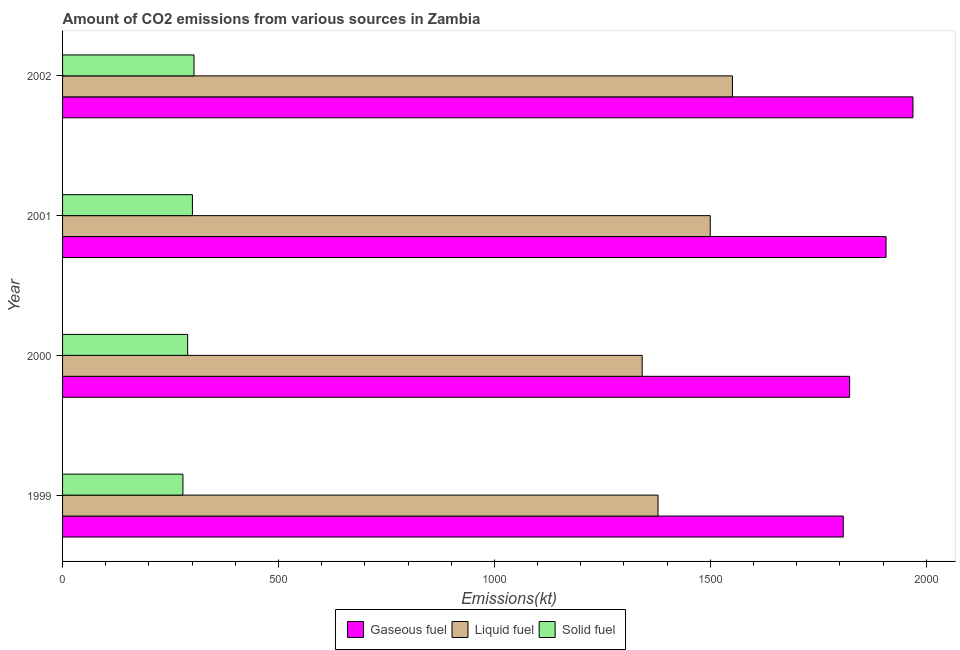How many different coloured bars are there?
Keep it short and to the point. 3. Are the number of bars per tick equal to the number of legend labels?
Make the answer very short. Yes. Are the number of bars on each tick of the Y-axis equal?
Provide a succinct answer. Yes. How many bars are there on the 4th tick from the top?
Make the answer very short. 3. What is the label of the 2nd group of bars from the top?
Your response must be concise. 2001. In how many cases, is the number of bars for a given year not equal to the number of legend labels?
Make the answer very short. 0. What is the amount of co2 emissions from gaseous fuel in 2000?
Provide a short and direct response. 1822.5. Across all years, what is the maximum amount of co2 emissions from solid fuel?
Offer a terse response. 304.36. Across all years, what is the minimum amount of co2 emissions from gaseous fuel?
Your response must be concise. 1807.83. In which year was the amount of co2 emissions from liquid fuel maximum?
Make the answer very short. 2002. In which year was the amount of co2 emissions from solid fuel minimum?
Give a very brief answer. 1999. What is the total amount of co2 emissions from solid fuel in the graph?
Offer a terse response. 1173.44. What is the difference between the amount of co2 emissions from gaseous fuel in 2000 and that in 2001?
Provide a short and direct response. -84.34. What is the difference between the amount of co2 emissions from solid fuel in 2000 and the amount of co2 emissions from liquid fuel in 2002?
Provide a succinct answer. -1261.45. What is the average amount of co2 emissions from liquid fuel per year?
Provide a succinct answer. 1442.96. In the year 2000, what is the difference between the amount of co2 emissions from gaseous fuel and amount of co2 emissions from liquid fuel?
Provide a short and direct response. 480.38. What is the ratio of the amount of co2 emissions from gaseous fuel in 1999 to that in 2001?
Ensure brevity in your answer.  0.95. Is the amount of co2 emissions from liquid fuel in 1999 less than that in 2000?
Keep it short and to the point. No. Is the difference between the amount of co2 emissions from gaseous fuel in 2000 and 2001 greater than the difference between the amount of co2 emissions from solid fuel in 2000 and 2001?
Offer a very short reply. No. What is the difference between the highest and the second highest amount of co2 emissions from gaseous fuel?
Offer a very short reply. 62.34. What is the difference between the highest and the lowest amount of co2 emissions from liquid fuel?
Provide a short and direct response. 209.02. In how many years, is the amount of co2 emissions from liquid fuel greater than the average amount of co2 emissions from liquid fuel taken over all years?
Your answer should be compact. 2. Is the sum of the amount of co2 emissions from liquid fuel in 2000 and 2002 greater than the maximum amount of co2 emissions from gaseous fuel across all years?
Provide a succinct answer. Yes. What does the 2nd bar from the top in 2001 represents?
Make the answer very short. Liquid fuel. What does the 3rd bar from the bottom in 1999 represents?
Make the answer very short. Solid fuel. Is it the case that in every year, the sum of the amount of co2 emissions from gaseous fuel and amount of co2 emissions from liquid fuel is greater than the amount of co2 emissions from solid fuel?
Provide a succinct answer. Yes. How many bars are there?
Provide a succinct answer. 12. What is the difference between two consecutive major ticks on the X-axis?
Ensure brevity in your answer.  500. Does the graph contain any zero values?
Give a very brief answer. No. Where does the legend appear in the graph?
Your response must be concise. Bottom center. How many legend labels are there?
Your answer should be compact. 3. What is the title of the graph?
Your answer should be compact. Amount of CO2 emissions from various sources in Zambia. What is the label or title of the X-axis?
Your answer should be compact. Emissions(kt). What is the Emissions(kt) in Gaseous fuel in 1999?
Ensure brevity in your answer.  1807.83. What is the Emissions(kt) in Liquid fuel in 1999?
Provide a succinct answer. 1378.79. What is the Emissions(kt) of Solid fuel in 1999?
Offer a terse response. 278.69. What is the Emissions(kt) in Gaseous fuel in 2000?
Ensure brevity in your answer.  1822.5. What is the Emissions(kt) of Liquid fuel in 2000?
Provide a short and direct response. 1342.12. What is the Emissions(kt) of Solid fuel in 2000?
Ensure brevity in your answer.  289.69. What is the Emissions(kt) of Gaseous fuel in 2001?
Offer a terse response. 1906.84. What is the Emissions(kt) in Liquid fuel in 2001?
Ensure brevity in your answer.  1499.8. What is the Emissions(kt) in Solid fuel in 2001?
Your response must be concise. 300.69. What is the Emissions(kt) of Gaseous fuel in 2002?
Your answer should be very brief. 1969.18. What is the Emissions(kt) in Liquid fuel in 2002?
Give a very brief answer. 1551.14. What is the Emissions(kt) of Solid fuel in 2002?
Your response must be concise. 304.36. Across all years, what is the maximum Emissions(kt) in Gaseous fuel?
Provide a short and direct response. 1969.18. Across all years, what is the maximum Emissions(kt) in Liquid fuel?
Make the answer very short. 1551.14. Across all years, what is the maximum Emissions(kt) of Solid fuel?
Provide a succinct answer. 304.36. Across all years, what is the minimum Emissions(kt) of Gaseous fuel?
Your response must be concise. 1807.83. Across all years, what is the minimum Emissions(kt) of Liquid fuel?
Give a very brief answer. 1342.12. Across all years, what is the minimum Emissions(kt) in Solid fuel?
Your response must be concise. 278.69. What is the total Emissions(kt) of Gaseous fuel in the graph?
Offer a terse response. 7506.35. What is the total Emissions(kt) in Liquid fuel in the graph?
Ensure brevity in your answer.  5771.86. What is the total Emissions(kt) in Solid fuel in the graph?
Your answer should be compact. 1173.44. What is the difference between the Emissions(kt) in Gaseous fuel in 1999 and that in 2000?
Ensure brevity in your answer.  -14.67. What is the difference between the Emissions(kt) in Liquid fuel in 1999 and that in 2000?
Give a very brief answer. 36.67. What is the difference between the Emissions(kt) in Solid fuel in 1999 and that in 2000?
Offer a terse response. -11. What is the difference between the Emissions(kt) in Gaseous fuel in 1999 and that in 2001?
Keep it short and to the point. -99.01. What is the difference between the Emissions(kt) in Liquid fuel in 1999 and that in 2001?
Keep it short and to the point. -121.01. What is the difference between the Emissions(kt) of Solid fuel in 1999 and that in 2001?
Offer a terse response. -22. What is the difference between the Emissions(kt) of Gaseous fuel in 1999 and that in 2002?
Your response must be concise. -161.35. What is the difference between the Emissions(kt) of Liquid fuel in 1999 and that in 2002?
Provide a short and direct response. -172.35. What is the difference between the Emissions(kt) of Solid fuel in 1999 and that in 2002?
Your answer should be compact. -25.67. What is the difference between the Emissions(kt) of Gaseous fuel in 2000 and that in 2001?
Your answer should be compact. -84.34. What is the difference between the Emissions(kt) of Liquid fuel in 2000 and that in 2001?
Offer a very short reply. -157.68. What is the difference between the Emissions(kt) of Solid fuel in 2000 and that in 2001?
Provide a short and direct response. -11. What is the difference between the Emissions(kt) in Gaseous fuel in 2000 and that in 2002?
Make the answer very short. -146.68. What is the difference between the Emissions(kt) in Liquid fuel in 2000 and that in 2002?
Provide a short and direct response. -209.02. What is the difference between the Emissions(kt) in Solid fuel in 2000 and that in 2002?
Your answer should be very brief. -14.67. What is the difference between the Emissions(kt) in Gaseous fuel in 2001 and that in 2002?
Give a very brief answer. -62.34. What is the difference between the Emissions(kt) in Liquid fuel in 2001 and that in 2002?
Your response must be concise. -51.34. What is the difference between the Emissions(kt) in Solid fuel in 2001 and that in 2002?
Offer a very short reply. -3.67. What is the difference between the Emissions(kt) of Gaseous fuel in 1999 and the Emissions(kt) of Liquid fuel in 2000?
Provide a short and direct response. 465.71. What is the difference between the Emissions(kt) of Gaseous fuel in 1999 and the Emissions(kt) of Solid fuel in 2000?
Provide a short and direct response. 1518.14. What is the difference between the Emissions(kt) of Liquid fuel in 1999 and the Emissions(kt) of Solid fuel in 2000?
Ensure brevity in your answer.  1089.1. What is the difference between the Emissions(kt) in Gaseous fuel in 1999 and the Emissions(kt) in Liquid fuel in 2001?
Provide a short and direct response. 308.03. What is the difference between the Emissions(kt) of Gaseous fuel in 1999 and the Emissions(kt) of Solid fuel in 2001?
Provide a short and direct response. 1507.14. What is the difference between the Emissions(kt) in Liquid fuel in 1999 and the Emissions(kt) in Solid fuel in 2001?
Give a very brief answer. 1078.1. What is the difference between the Emissions(kt) in Gaseous fuel in 1999 and the Emissions(kt) in Liquid fuel in 2002?
Ensure brevity in your answer.  256.69. What is the difference between the Emissions(kt) of Gaseous fuel in 1999 and the Emissions(kt) of Solid fuel in 2002?
Offer a terse response. 1503.47. What is the difference between the Emissions(kt) in Liquid fuel in 1999 and the Emissions(kt) in Solid fuel in 2002?
Your response must be concise. 1074.43. What is the difference between the Emissions(kt) in Gaseous fuel in 2000 and the Emissions(kt) in Liquid fuel in 2001?
Your answer should be compact. 322.7. What is the difference between the Emissions(kt) of Gaseous fuel in 2000 and the Emissions(kt) of Solid fuel in 2001?
Give a very brief answer. 1521.81. What is the difference between the Emissions(kt) in Liquid fuel in 2000 and the Emissions(kt) in Solid fuel in 2001?
Your answer should be compact. 1041.43. What is the difference between the Emissions(kt) in Gaseous fuel in 2000 and the Emissions(kt) in Liquid fuel in 2002?
Give a very brief answer. 271.36. What is the difference between the Emissions(kt) in Gaseous fuel in 2000 and the Emissions(kt) in Solid fuel in 2002?
Your response must be concise. 1518.14. What is the difference between the Emissions(kt) of Liquid fuel in 2000 and the Emissions(kt) of Solid fuel in 2002?
Ensure brevity in your answer.  1037.76. What is the difference between the Emissions(kt) of Gaseous fuel in 2001 and the Emissions(kt) of Liquid fuel in 2002?
Offer a very short reply. 355.7. What is the difference between the Emissions(kt) of Gaseous fuel in 2001 and the Emissions(kt) of Solid fuel in 2002?
Offer a terse response. 1602.48. What is the difference between the Emissions(kt) of Liquid fuel in 2001 and the Emissions(kt) of Solid fuel in 2002?
Your response must be concise. 1195.44. What is the average Emissions(kt) of Gaseous fuel per year?
Ensure brevity in your answer.  1876.59. What is the average Emissions(kt) of Liquid fuel per year?
Offer a very short reply. 1442.96. What is the average Emissions(kt) in Solid fuel per year?
Your response must be concise. 293.36. In the year 1999, what is the difference between the Emissions(kt) of Gaseous fuel and Emissions(kt) of Liquid fuel?
Provide a short and direct response. 429.04. In the year 1999, what is the difference between the Emissions(kt) in Gaseous fuel and Emissions(kt) in Solid fuel?
Your answer should be compact. 1529.14. In the year 1999, what is the difference between the Emissions(kt) of Liquid fuel and Emissions(kt) of Solid fuel?
Offer a terse response. 1100.1. In the year 2000, what is the difference between the Emissions(kt) of Gaseous fuel and Emissions(kt) of Liquid fuel?
Your answer should be very brief. 480.38. In the year 2000, what is the difference between the Emissions(kt) of Gaseous fuel and Emissions(kt) of Solid fuel?
Your answer should be very brief. 1532.81. In the year 2000, what is the difference between the Emissions(kt) of Liquid fuel and Emissions(kt) of Solid fuel?
Your answer should be very brief. 1052.43. In the year 2001, what is the difference between the Emissions(kt) in Gaseous fuel and Emissions(kt) in Liquid fuel?
Give a very brief answer. 407.04. In the year 2001, what is the difference between the Emissions(kt) in Gaseous fuel and Emissions(kt) in Solid fuel?
Your answer should be very brief. 1606.15. In the year 2001, what is the difference between the Emissions(kt) in Liquid fuel and Emissions(kt) in Solid fuel?
Your answer should be very brief. 1199.11. In the year 2002, what is the difference between the Emissions(kt) of Gaseous fuel and Emissions(kt) of Liquid fuel?
Provide a succinct answer. 418.04. In the year 2002, what is the difference between the Emissions(kt) in Gaseous fuel and Emissions(kt) in Solid fuel?
Ensure brevity in your answer.  1664.82. In the year 2002, what is the difference between the Emissions(kt) in Liquid fuel and Emissions(kt) in Solid fuel?
Offer a very short reply. 1246.78. What is the ratio of the Emissions(kt) in Liquid fuel in 1999 to that in 2000?
Offer a very short reply. 1.03. What is the ratio of the Emissions(kt) in Solid fuel in 1999 to that in 2000?
Your answer should be compact. 0.96. What is the ratio of the Emissions(kt) in Gaseous fuel in 1999 to that in 2001?
Your answer should be compact. 0.95. What is the ratio of the Emissions(kt) in Liquid fuel in 1999 to that in 2001?
Ensure brevity in your answer.  0.92. What is the ratio of the Emissions(kt) in Solid fuel in 1999 to that in 2001?
Your answer should be very brief. 0.93. What is the ratio of the Emissions(kt) of Gaseous fuel in 1999 to that in 2002?
Your answer should be compact. 0.92. What is the ratio of the Emissions(kt) in Solid fuel in 1999 to that in 2002?
Keep it short and to the point. 0.92. What is the ratio of the Emissions(kt) of Gaseous fuel in 2000 to that in 2001?
Offer a terse response. 0.96. What is the ratio of the Emissions(kt) of Liquid fuel in 2000 to that in 2001?
Keep it short and to the point. 0.89. What is the ratio of the Emissions(kt) in Solid fuel in 2000 to that in 2001?
Ensure brevity in your answer.  0.96. What is the ratio of the Emissions(kt) of Gaseous fuel in 2000 to that in 2002?
Your response must be concise. 0.93. What is the ratio of the Emissions(kt) in Liquid fuel in 2000 to that in 2002?
Keep it short and to the point. 0.87. What is the ratio of the Emissions(kt) in Solid fuel in 2000 to that in 2002?
Provide a short and direct response. 0.95. What is the ratio of the Emissions(kt) of Gaseous fuel in 2001 to that in 2002?
Ensure brevity in your answer.  0.97. What is the ratio of the Emissions(kt) in Liquid fuel in 2001 to that in 2002?
Offer a very short reply. 0.97. What is the difference between the highest and the second highest Emissions(kt) of Gaseous fuel?
Keep it short and to the point. 62.34. What is the difference between the highest and the second highest Emissions(kt) of Liquid fuel?
Offer a very short reply. 51.34. What is the difference between the highest and the second highest Emissions(kt) of Solid fuel?
Give a very brief answer. 3.67. What is the difference between the highest and the lowest Emissions(kt) of Gaseous fuel?
Your response must be concise. 161.35. What is the difference between the highest and the lowest Emissions(kt) in Liquid fuel?
Keep it short and to the point. 209.02. What is the difference between the highest and the lowest Emissions(kt) in Solid fuel?
Make the answer very short. 25.67. 